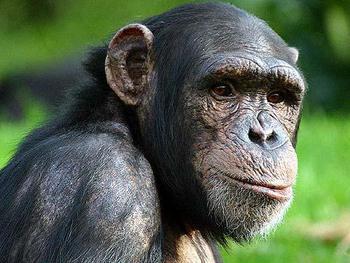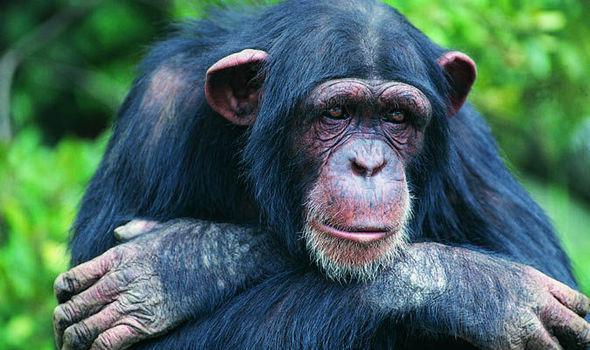The first image is the image on the left, the second image is the image on the right. Considering the images on both sides, is "In one of the images a baby monkey is cuddling its mother." valid? Answer yes or no. No. 